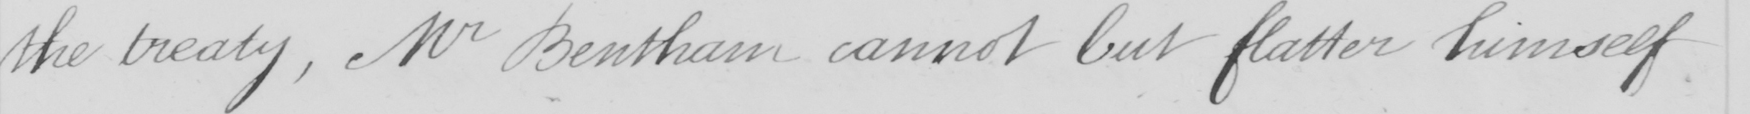Transcribe the text shown in this historical manuscript line. the treaty , Mr Bentham cannot but flatter himself 